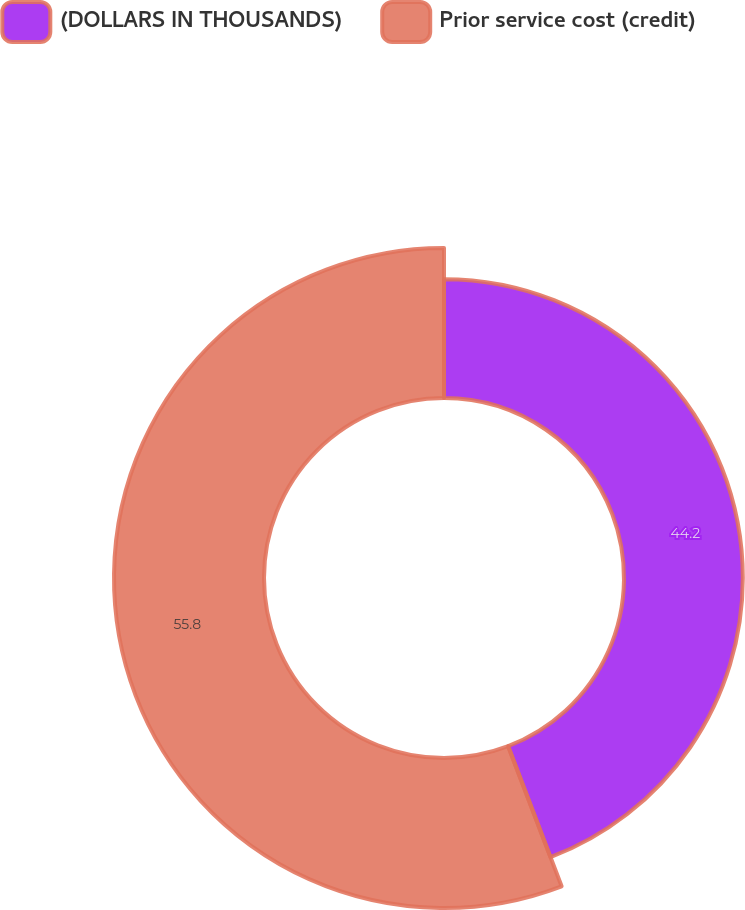<chart> <loc_0><loc_0><loc_500><loc_500><pie_chart><fcel>(DOLLARS IN THOUSANDS)<fcel>Prior service cost (credit)<nl><fcel>44.2%<fcel>55.8%<nl></chart> 